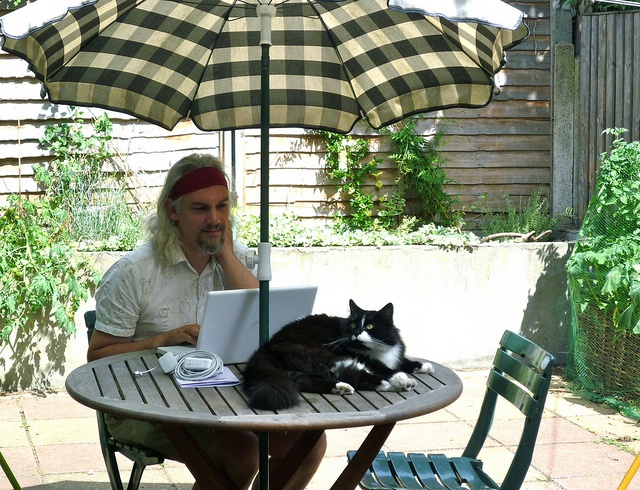Describe the objects in this image and their specific colors. I can see umbrella in black, gray, olive, and darkgray tones, people in black, gray, and darkgray tones, dining table in black, darkgray, and gray tones, potted plant in black, darkgreen, and green tones, and cat in black, gray, lightgray, and darkgray tones in this image. 